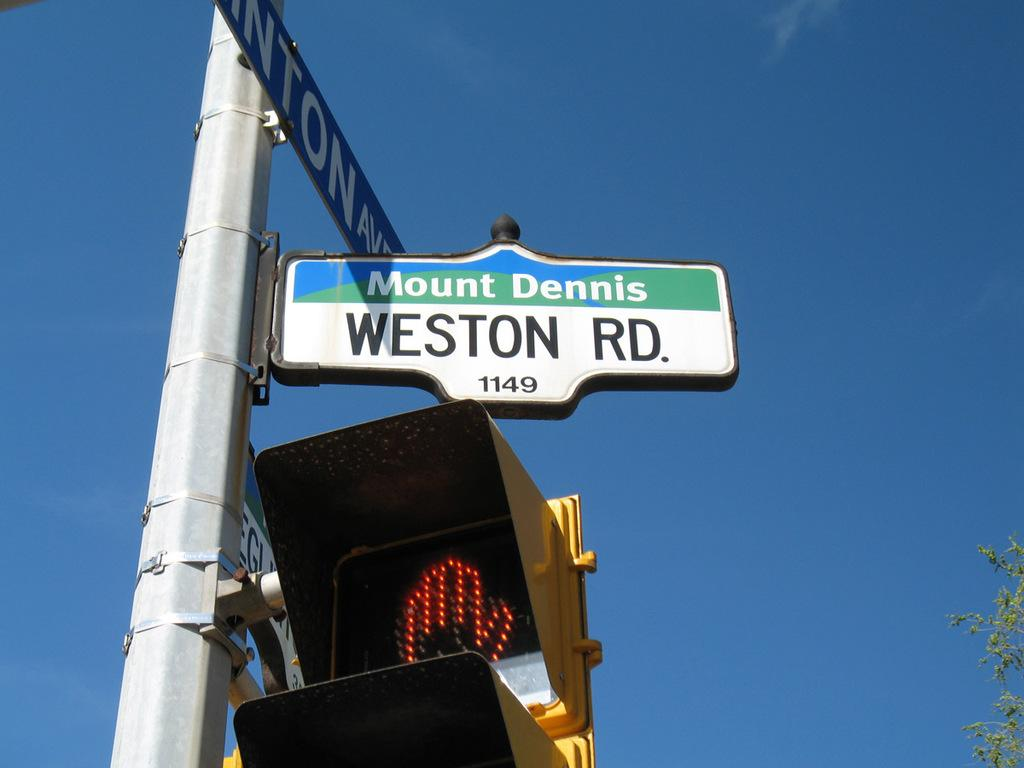<image>
Describe the image concisely. A sign for Weston Road has the number 1149 on it. 